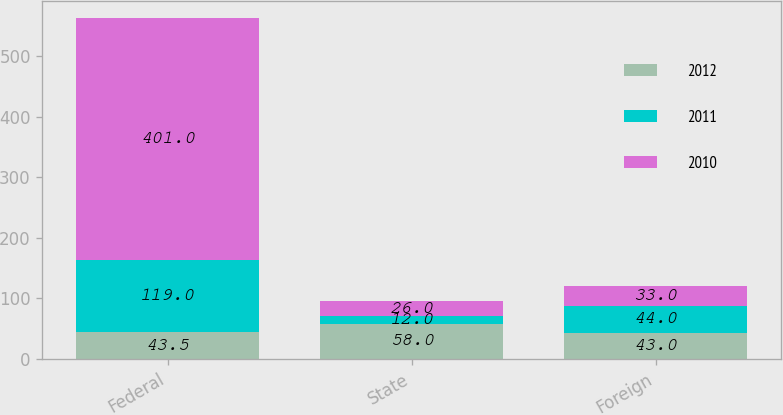<chart> <loc_0><loc_0><loc_500><loc_500><stacked_bar_chart><ecel><fcel>Federal<fcel>State<fcel>Foreign<nl><fcel>2012<fcel>43.5<fcel>58<fcel>43<nl><fcel>2011<fcel>119<fcel>12<fcel>44<nl><fcel>2010<fcel>401<fcel>26<fcel>33<nl></chart> 